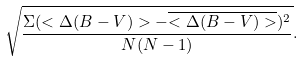<formula> <loc_0><loc_0><loc_500><loc_500>\sqrt { \frac { \Sigma ( < \Delta ( B - V ) > - \overline { < \Delta ( B - V ) > } ) ^ { 2 } } { N ( N - 1 ) } } .</formula> 